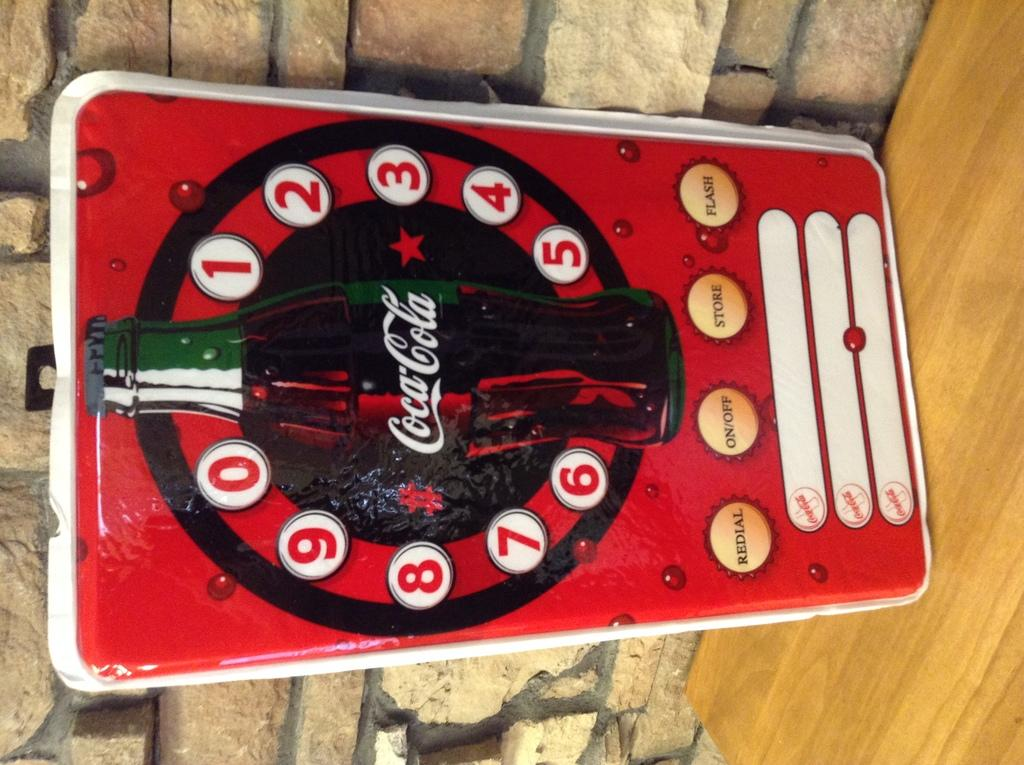What is the main subject in the center of the image? There is a poster in the center of the image. What is depicted on the poster? The poster features a coca cola bottle. How many chairs are visible in the image? There are no chairs visible in the image; it only features a poster with a coca cola bottle. What type of grain is being harvested in the image? There is no grain or harvesting activity present in the image; it only features a poster with a coca cola bottle. 